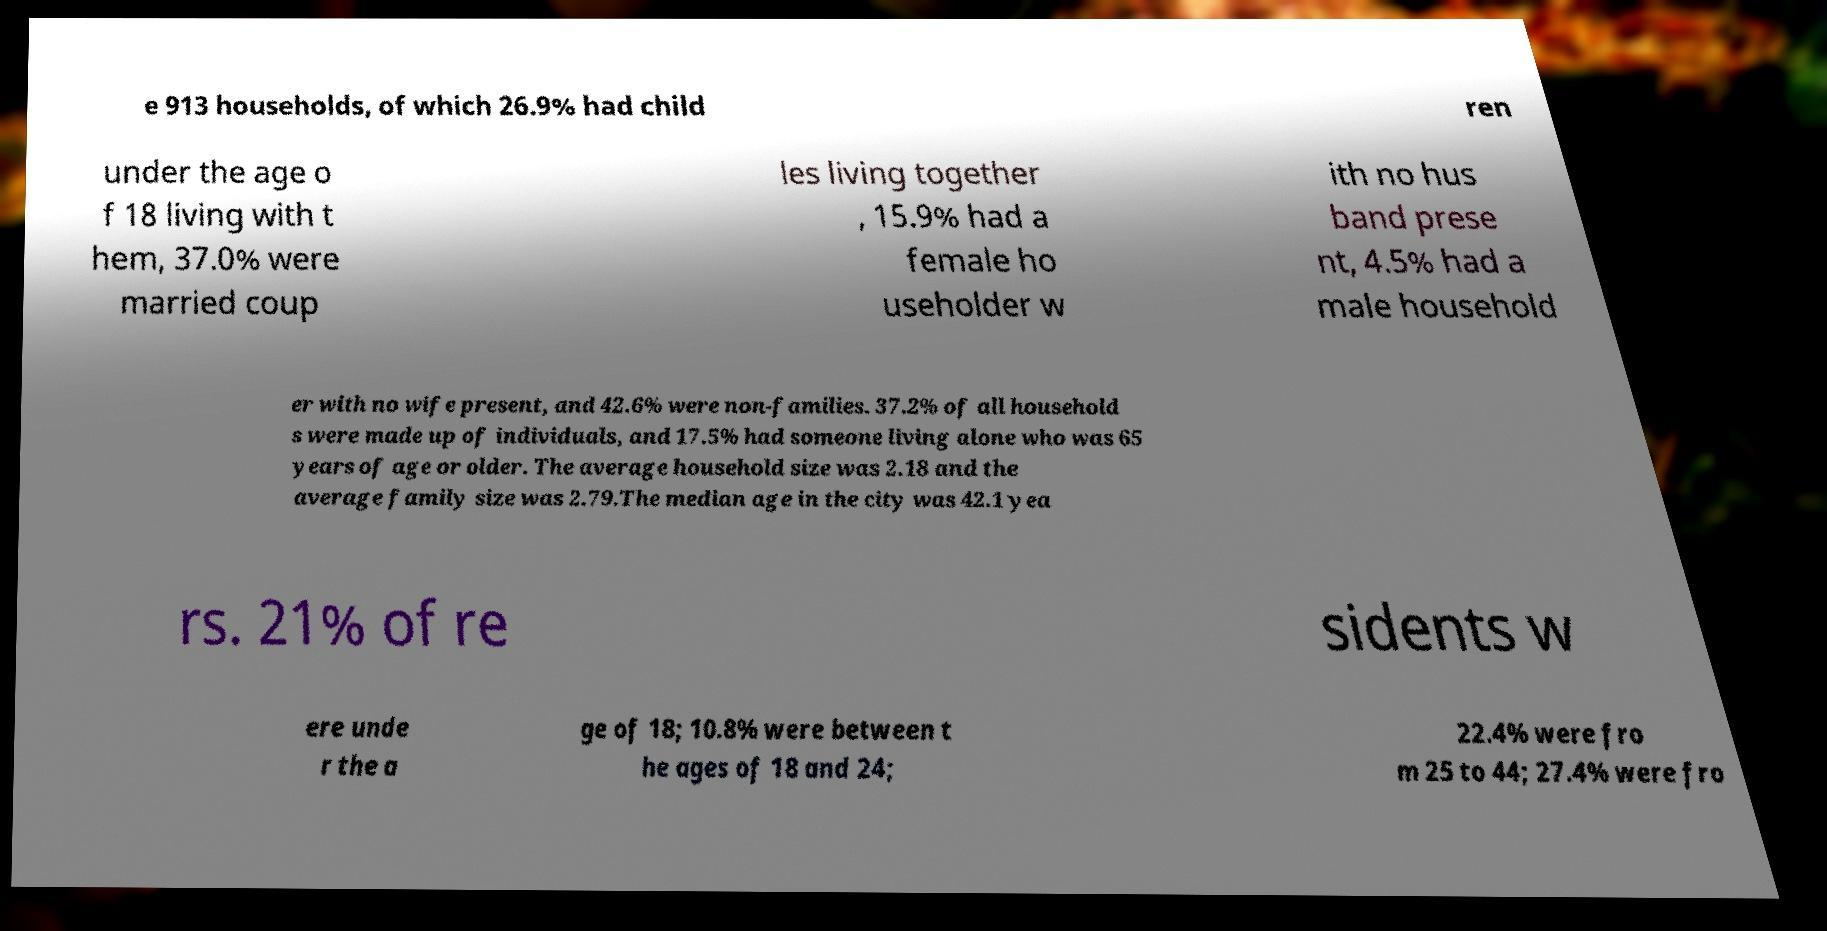For documentation purposes, I need the text within this image transcribed. Could you provide that? e 913 households, of which 26.9% had child ren under the age o f 18 living with t hem, 37.0% were married coup les living together , 15.9% had a female ho useholder w ith no hus band prese nt, 4.5% had a male household er with no wife present, and 42.6% were non-families. 37.2% of all household s were made up of individuals, and 17.5% had someone living alone who was 65 years of age or older. The average household size was 2.18 and the average family size was 2.79.The median age in the city was 42.1 yea rs. 21% of re sidents w ere unde r the a ge of 18; 10.8% were between t he ages of 18 and 24; 22.4% were fro m 25 to 44; 27.4% were fro 